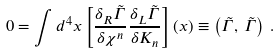<formula> <loc_0><loc_0><loc_500><loc_500>0 = \int d ^ { 4 } x \left [ \frac { \delta _ { R } \tilde { \Gamma } } { \delta \chi ^ { n } } \frac { \delta _ { L } \tilde { \Gamma } } { \delta K _ { n } } \right ] ( x ) \equiv \left ( \tilde { \Gamma } , \, \tilde { \Gamma } \right ) \, .</formula> 